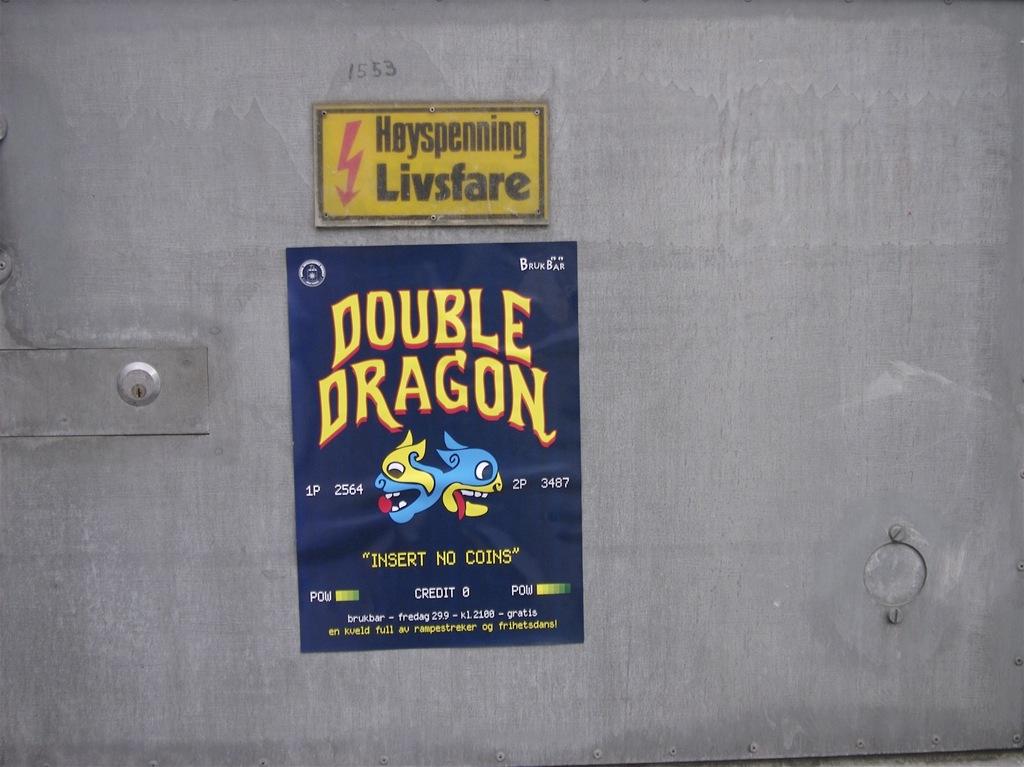What is the name on the poster?
Your answer should be very brief. Double dragon. Insert no what?
Your response must be concise. Coins. 